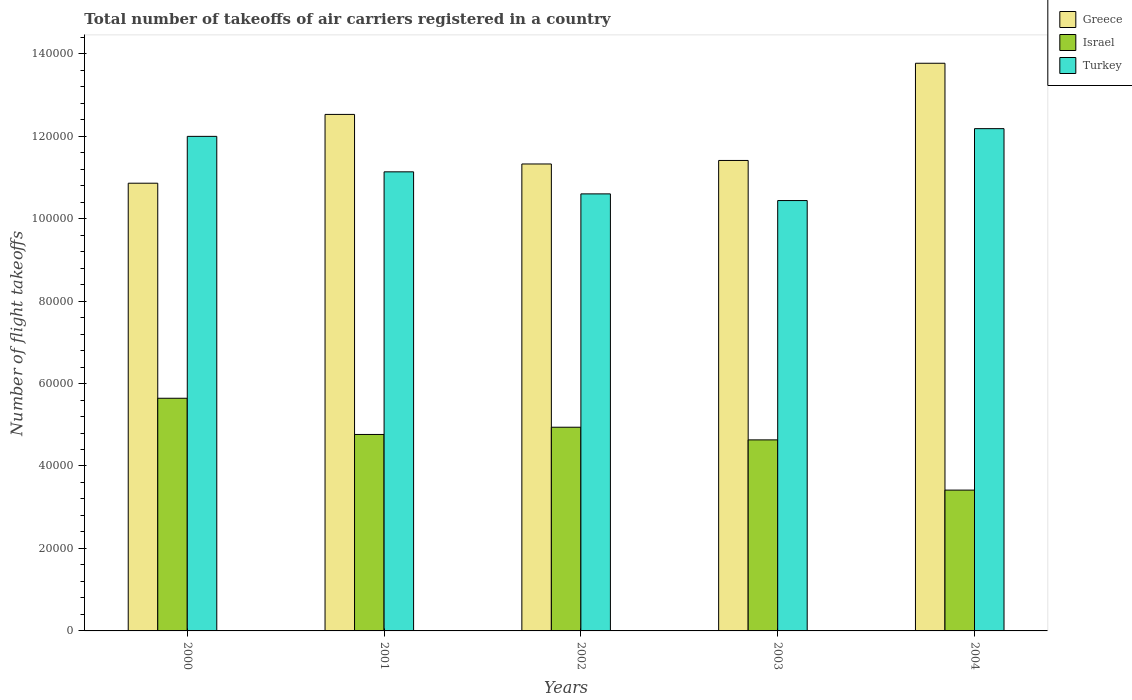How many different coloured bars are there?
Your answer should be compact. 3. How many groups of bars are there?
Your response must be concise. 5. How many bars are there on the 2nd tick from the right?
Offer a terse response. 3. What is the total number of flight takeoffs in Israel in 2001?
Give a very brief answer. 4.76e+04. Across all years, what is the maximum total number of flight takeoffs in Greece?
Ensure brevity in your answer.  1.38e+05. Across all years, what is the minimum total number of flight takeoffs in Greece?
Offer a terse response. 1.09e+05. In which year was the total number of flight takeoffs in Turkey minimum?
Offer a very short reply. 2003. What is the total total number of flight takeoffs in Turkey in the graph?
Your response must be concise. 5.63e+05. What is the difference between the total number of flight takeoffs in Greece in 2002 and that in 2004?
Offer a terse response. -2.44e+04. What is the difference between the total number of flight takeoffs in Israel in 2003 and the total number of flight takeoffs in Turkey in 2004?
Your answer should be very brief. -7.55e+04. What is the average total number of flight takeoffs in Turkey per year?
Your answer should be compact. 1.13e+05. In the year 2003, what is the difference between the total number of flight takeoffs in Israel and total number of flight takeoffs in Turkey?
Keep it short and to the point. -5.80e+04. In how many years, is the total number of flight takeoffs in Greece greater than 116000?
Your answer should be compact. 2. What is the ratio of the total number of flight takeoffs in Greece in 2001 to that in 2003?
Your response must be concise. 1.1. What is the difference between the highest and the second highest total number of flight takeoffs in Turkey?
Your response must be concise. 1870. What is the difference between the highest and the lowest total number of flight takeoffs in Israel?
Your answer should be compact. 2.23e+04. In how many years, is the total number of flight takeoffs in Greece greater than the average total number of flight takeoffs in Greece taken over all years?
Provide a succinct answer. 2. Is the sum of the total number of flight takeoffs in Turkey in 2000 and 2002 greater than the maximum total number of flight takeoffs in Greece across all years?
Make the answer very short. Yes. What does the 1st bar from the left in 2000 represents?
Offer a very short reply. Greece. What does the 1st bar from the right in 2000 represents?
Ensure brevity in your answer.  Turkey. Is it the case that in every year, the sum of the total number of flight takeoffs in Turkey and total number of flight takeoffs in Greece is greater than the total number of flight takeoffs in Israel?
Your answer should be compact. Yes. Are all the bars in the graph horizontal?
Provide a succinct answer. No. How many years are there in the graph?
Provide a succinct answer. 5. Are the values on the major ticks of Y-axis written in scientific E-notation?
Provide a succinct answer. No. Where does the legend appear in the graph?
Ensure brevity in your answer.  Top right. What is the title of the graph?
Provide a succinct answer. Total number of takeoffs of air carriers registered in a country. What is the label or title of the X-axis?
Your answer should be compact. Years. What is the label or title of the Y-axis?
Offer a very short reply. Number of flight takeoffs. What is the Number of flight takeoffs of Greece in 2000?
Offer a very short reply. 1.09e+05. What is the Number of flight takeoffs of Israel in 2000?
Keep it short and to the point. 5.64e+04. What is the Number of flight takeoffs in Turkey in 2000?
Make the answer very short. 1.20e+05. What is the Number of flight takeoffs in Greece in 2001?
Your response must be concise. 1.25e+05. What is the Number of flight takeoffs of Israel in 2001?
Your response must be concise. 4.76e+04. What is the Number of flight takeoffs in Turkey in 2001?
Give a very brief answer. 1.11e+05. What is the Number of flight takeoffs of Greece in 2002?
Make the answer very short. 1.13e+05. What is the Number of flight takeoffs in Israel in 2002?
Offer a very short reply. 4.94e+04. What is the Number of flight takeoffs of Turkey in 2002?
Your answer should be very brief. 1.06e+05. What is the Number of flight takeoffs of Greece in 2003?
Offer a very short reply. 1.14e+05. What is the Number of flight takeoffs of Israel in 2003?
Offer a terse response. 4.63e+04. What is the Number of flight takeoffs in Turkey in 2003?
Your answer should be very brief. 1.04e+05. What is the Number of flight takeoffs of Greece in 2004?
Provide a succinct answer. 1.38e+05. What is the Number of flight takeoffs of Israel in 2004?
Give a very brief answer. 3.42e+04. What is the Number of flight takeoffs of Turkey in 2004?
Keep it short and to the point. 1.22e+05. Across all years, what is the maximum Number of flight takeoffs of Greece?
Your answer should be compact. 1.38e+05. Across all years, what is the maximum Number of flight takeoffs of Israel?
Offer a very short reply. 5.64e+04. Across all years, what is the maximum Number of flight takeoffs in Turkey?
Offer a terse response. 1.22e+05. Across all years, what is the minimum Number of flight takeoffs in Greece?
Make the answer very short. 1.09e+05. Across all years, what is the minimum Number of flight takeoffs in Israel?
Make the answer very short. 3.42e+04. Across all years, what is the minimum Number of flight takeoffs of Turkey?
Keep it short and to the point. 1.04e+05. What is the total Number of flight takeoffs in Greece in the graph?
Give a very brief answer. 5.99e+05. What is the total Number of flight takeoffs of Israel in the graph?
Make the answer very short. 2.34e+05. What is the total Number of flight takeoffs of Turkey in the graph?
Your answer should be compact. 5.63e+05. What is the difference between the Number of flight takeoffs of Greece in 2000 and that in 2001?
Keep it short and to the point. -1.67e+04. What is the difference between the Number of flight takeoffs of Israel in 2000 and that in 2001?
Offer a terse response. 8779. What is the difference between the Number of flight takeoffs of Turkey in 2000 and that in 2001?
Provide a short and direct response. 8603. What is the difference between the Number of flight takeoffs in Greece in 2000 and that in 2002?
Your response must be concise. -4663. What is the difference between the Number of flight takeoffs in Israel in 2000 and that in 2002?
Give a very brief answer. 7023. What is the difference between the Number of flight takeoffs of Turkey in 2000 and that in 2002?
Offer a very short reply. 1.39e+04. What is the difference between the Number of flight takeoffs in Greece in 2000 and that in 2003?
Keep it short and to the point. -5516. What is the difference between the Number of flight takeoffs in Israel in 2000 and that in 2003?
Your answer should be compact. 1.01e+04. What is the difference between the Number of flight takeoffs in Turkey in 2000 and that in 2003?
Give a very brief answer. 1.56e+04. What is the difference between the Number of flight takeoffs of Greece in 2000 and that in 2004?
Provide a short and direct response. -2.91e+04. What is the difference between the Number of flight takeoffs of Israel in 2000 and that in 2004?
Provide a succinct answer. 2.23e+04. What is the difference between the Number of flight takeoffs in Turkey in 2000 and that in 2004?
Keep it short and to the point. -1870. What is the difference between the Number of flight takeoffs in Greece in 2001 and that in 2002?
Give a very brief answer. 1.20e+04. What is the difference between the Number of flight takeoffs of Israel in 2001 and that in 2002?
Your answer should be compact. -1756. What is the difference between the Number of flight takeoffs of Turkey in 2001 and that in 2002?
Your response must be concise. 5346. What is the difference between the Number of flight takeoffs in Greece in 2001 and that in 2003?
Offer a terse response. 1.12e+04. What is the difference between the Number of flight takeoffs of Israel in 2001 and that in 2003?
Ensure brevity in your answer.  1314. What is the difference between the Number of flight takeoffs of Turkey in 2001 and that in 2003?
Provide a short and direct response. 6965. What is the difference between the Number of flight takeoffs in Greece in 2001 and that in 2004?
Provide a succinct answer. -1.24e+04. What is the difference between the Number of flight takeoffs in Israel in 2001 and that in 2004?
Your answer should be compact. 1.35e+04. What is the difference between the Number of flight takeoffs in Turkey in 2001 and that in 2004?
Your answer should be compact. -1.05e+04. What is the difference between the Number of flight takeoffs in Greece in 2002 and that in 2003?
Your answer should be very brief. -853. What is the difference between the Number of flight takeoffs of Israel in 2002 and that in 2003?
Offer a very short reply. 3070. What is the difference between the Number of flight takeoffs in Turkey in 2002 and that in 2003?
Offer a terse response. 1619. What is the difference between the Number of flight takeoffs of Greece in 2002 and that in 2004?
Your answer should be compact. -2.44e+04. What is the difference between the Number of flight takeoffs of Israel in 2002 and that in 2004?
Offer a terse response. 1.53e+04. What is the difference between the Number of flight takeoffs in Turkey in 2002 and that in 2004?
Your answer should be very brief. -1.58e+04. What is the difference between the Number of flight takeoffs in Greece in 2003 and that in 2004?
Offer a terse response. -2.36e+04. What is the difference between the Number of flight takeoffs of Israel in 2003 and that in 2004?
Your answer should be compact. 1.22e+04. What is the difference between the Number of flight takeoffs in Turkey in 2003 and that in 2004?
Ensure brevity in your answer.  -1.74e+04. What is the difference between the Number of flight takeoffs of Greece in 2000 and the Number of flight takeoffs of Israel in 2001?
Provide a succinct answer. 6.09e+04. What is the difference between the Number of flight takeoffs of Greece in 2000 and the Number of flight takeoffs of Turkey in 2001?
Your response must be concise. -2758. What is the difference between the Number of flight takeoffs of Israel in 2000 and the Number of flight takeoffs of Turkey in 2001?
Provide a short and direct response. -5.49e+04. What is the difference between the Number of flight takeoffs of Greece in 2000 and the Number of flight takeoffs of Israel in 2002?
Your answer should be compact. 5.92e+04. What is the difference between the Number of flight takeoffs of Greece in 2000 and the Number of flight takeoffs of Turkey in 2002?
Make the answer very short. 2588. What is the difference between the Number of flight takeoffs of Israel in 2000 and the Number of flight takeoffs of Turkey in 2002?
Ensure brevity in your answer.  -4.96e+04. What is the difference between the Number of flight takeoffs in Greece in 2000 and the Number of flight takeoffs in Israel in 2003?
Offer a terse response. 6.22e+04. What is the difference between the Number of flight takeoffs in Greece in 2000 and the Number of flight takeoffs in Turkey in 2003?
Your response must be concise. 4207. What is the difference between the Number of flight takeoffs of Israel in 2000 and the Number of flight takeoffs of Turkey in 2003?
Provide a short and direct response. -4.80e+04. What is the difference between the Number of flight takeoffs in Greece in 2000 and the Number of flight takeoffs in Israel in 2004?
Provide a succinct answer. 7.44e+04. What is the difference between the Number of flight takeoffs in Greece in 2000 and the Number of flight takeoffs in Turkey in 2004?
Provide a short and direct response. -1.32e+04. What is the difference between the Number of flight takeoffs in Israel in 2000 and the Number of flight takeoffs in Turkey in 2004?
Your answer should be compact. -6.54e+04. What is the difference between the Number of flight takeoffs in Greece in 2001 and the Number of flight takeoffs in Israel in 2002?
Offer a terse response. 7.59e+04. What is the difference between the Number of flight takeoffs in Greece in 2001 and the Number of flight takeoffs in Turkey in 2002?
Your response must be concise. 1.93e+04. What is the difference between the Number of flight takeoffs in Israel in 2001 and the Number of flight takeoffs in Turkey in 2002?
Make the answer very short. -5.83e+04. What is the difference between the Number of flight takeoffs of Greece in 2001 and the Number of flight takeoffs of Israel in 2003?
Your answer should be compact. 7.89e+04. What is the difference between the Number of flight takeoffs of Greece in 2001 and the Number of flight takeoffs of Turkey in 2003?
Ensure brevity in your answer.  2.09e+04. What is the difference between the Number of flight takeoffs of Israel in 2001 and the Number of flight takeoffs of Turkey in 2003?
Make the answer very short. -5.67e+04. What is the difference between the Number of flight takeoffs in Greece in 2001 and the Number of flight takeoffs in Israel in 2004?
Make the answer very short. 9.11e+04. What is the difference between the Number of flight takeoffs of Greece in 2001 and the Number of flight takeoffs of Turkey in 2004?
Keep it short and to the point. 3454. What is the difference between the Number of flight takeoffs in Israel in 2001 and the Number of flight takeoffs in Turkey in 2004?
Ensure brevity in your answer.  -7.42e+04. What is the difference between the Number of flight takeoffs of Greece in 2002 and the Number of flight takeoffs of Israel in 2003?
Your response must be concise. 6.69e+04. What is the difference between the Number of flight takeoffs in Greece in 2002 and the Number of flight takeoffs in Turkey in 2003?
Provide a succinct answer. 8870. What is the difference between the Number of flight takeoffs in Israel in 2002 and the Number of flight takeoffs in Turkey in 2003?
Offer a terse response. -5.50e+04. What is the difference between the Number of flight takeoffs of Greece in 2002 and the Number of flight takeoffs of Israel in 2004?
Your answer should be very brief. 7.91e+04. What is the difference between the Number of flight takeoffs of Greece in 2002 and the Number of flight takeoffs of Turkey in 2004?
Provide a succinct answer. -8568. What is the difference between the Number of flight takeoffs in Israel in 2002 and the Number of flight takeoffs in Turkey in 2004?
Give a very brief answer. -7.24e+04. What is the difference between the Number of flight takeoffs of Greece in 2003 and the Number of flight takeoffs of Israel in 2004?
Ensure brevity in your answer.  7.99e+04. What is the difference between the Number of flight takeoffs in Greece in 2003 and the Number of flight takeoffs in Turkey in 2004?
Ensure brevity in your answer.  -7715. What is the difference between the Number of flight takeoffs of Israel in 2003 and the Number of flight takeoffs of Turkey in 2004?
Make the answer very short. -7.55e+04. What is the average Number of flight takeoffs of Greece per year?
Make the answer very short. 1.20e+05. What is the average Number of flight takeoffs in Israel per year?
Offer a very short reply. 4.68e+04. What is the average Number of flight takeoffs in Turkey per year?
Your response must be concise. 1.13e+05. In the year 2000, what is the difference between the Number of flight takeoffs in Greece and Number of flight takeoffs in Israel?
Ensure brevity in your answer.  5.22e+04. In the year 2000, what is the difference between the Number of flight takeoffs of Greece and Number of flight takeoffs of Turkey?
Give a very brief answer. -1.14e+04. In the year 2000, what is the difference between the Number of flight takeoffs in Israel and Number of flight takeoffs in Turkey?
Make the answer very short. -6.35e+04. In the year 2001, what is the difference between the Number of flight takeoffs in Greece and Number of flight takeoffs in Israel?
Provide a succinct answer. 7.76e+04. In the year 2001, what is the difference between the Number of flight takeoffs in Greece and Number of flight takeoffs in Turkey?
Offer a terse response. 1.39e+04. In the year 2001, what is the difference between the Number of flight takeoffs in Israel and Number of flight takeoffs in Turkey?
Make the answer very short. -6.37e+04. In the year 2002, what is the difference between the Number of flight takeoffs of Greece and Number of flight takeoffs of Israel?
Give a very brief answer. 6.38e+04. In the year 2002, what is the difference between the Number of flight takeoffs of Greece and Number of flight takeoffs of Turkey?
Provide a succinct answer. 7251. In the year 2002, what is the difference between the Number of flight takeoffs of Israel and Number of flight takeoffs of Turkey?
Make the answer very short. -5.66e+04. In the year 2003, what is the difference between the Number of flight takeoffs of Greece and Number of flight takeoffs of Israel?
Offer a terse response. 6.78e+04. In the year 2003, what is the difference between the Number of flight takeoffs of Greece and Number of flight takeoffs of Turkey?
Your answer should be very brief. 9723. In the year 2003, what is the difference between the Number of flight takeoffs in Israel and Number of flight takeoffs in Turkey?
Offer a terse response. -5.80e+04. In the year 2004, what is the difference between the Number of flight takeoffs in Greece and Number of flight takeoffs in Israel?
Your answer should be very brief. 1.04e+05. In the year 2004, what is the difference between the Number of flight takeoffs of Greece and Number of flight takeoffs of Turkey?
Give a very brief answer. 1.59e+04. In the year 2004, what is the difference between the Number of flight takeoffs of Israel and Number of flight takeoffs of Turkey?
Ensure brevity in your answer.  -8.77e+04. What is the ratio of the Number of flight takeoffs in Greece in 2000 to that in 2001?
Your answer should be very brief. 0.87. What is the ratio of the Number of flight takeoffs in Israel in 2000 to that in 2001?
Your answer should be very brief. 1.18. What is the ratio of the Number of flight takeoffs of Turkey in 2000 to that in 2001?
Provide a short and direct response. 1.08. What is the ratio of the Number of flight takeoffs in Greece in 2000 to that in 2002?
Offer a very short reply. 0.96. What is the ratio of the Number of flight takeoffs in Israel in 2000 to that in 2002?
Make the answer very short. 1.14. What is the ratio of the Number of flight takeoffs in Turkey in 2000 to that in 2002?
Offer a very short reply. 1.13. What is the ratio of the Number of flight takeoffs in Greece in 2000 to that in 2003?
Make the answer very short. 0.95. What is the ratio of the Number of flight takeoffs of Israel in 2000 to that in 2003?
Give a very brief answer. 1.22. What is the ratio of the Number of flight takeoffs in Turkey in 2000 to that in 2003?
Offer a terse response. 1.15. What is the ratio of the Number of flight takeoffs of Greece in 2000 to that in 2004?
Your answer should be compact. 0.79. What is the ratio of the Number of flight takeoffs in Israel in 2000 to that in 2004?
Provide a short and direct response. 1.65. What is the ratio of the Number of flight takeoffs of Turkey in 2000 to that in 2004?
Your response must be concise. 0.98. What is the ratio of the Number of flight takeoffs of Greece in 2001 to that in 2002?
Ensure brevity in your answer.  1.11. What is the ratio of the Number of flight takeoffs of Israel in 2001 to that in 2002?
Your response must be concise. 0.96. What is the ratio of the Number of flight takeoffs in Turkey in 2001 to that in 2002?
Give a very brief answer. 1.05. What is the ratio of the Number of flight takeoffs in Greece in 2001 to that in 2003?
Provide a short and direct response. 1.1. What is the ratio of the Number of flight takeoffs of Israel in 2001 to that in 2003?
Your answer should be very brief. 1.03. What is the ratio of the Number of flight takeoffs of Turkey in 2001 to that in 2003?
Your response must be concise. 1.07. What is the ratio of the Number of flight takeoffs in Greece in 2001 to that in 2004?
Ensure brevity in your answer.  0.91. What is the ratio of the Number of flight takeoffs of Israel in 2001 to that in 2004?
Your answer should be compact. 1.4. What is the ratio of the Number of flight takeoffs in Turkey in 2001 to that in 2004?
Offer a very short reply. 0.91. What is the ratio of the Number of flight takeoffs of Greece in 2002 to that in 2003?
Your answer should be very brief. 0.99. What is the ratio of the Number of flight takeoffs of Israel in 2002 to that in 2003?
Provide a short and direct response. 1.07. What is the ratio of the Number of flight takeoffs of Turkey in 2002 to that in 2003?
Make the answer very short. 1.02. What is the ratio of the Number of flight takeoffs in Greece in 2002 to that in 2004?
Make the answer very short. 0.82. What is the ratio of the Number of flight takeoffs of Israel in 2002 to that in 2004?
Your answer should be very brief. 1.45. What is the ratio of the Number of flight takeoffs of Turkey in 2002 to that in 2004?
Keep it short and to the point. 0.87. What is the ratio of the Number of flight takeoffs in Greece in 2003 to that in 2004?
Your answer should be compact. 0.83. What is the ratio of the Number of flight takeoffs of Israel in 2003 to that in 2004?
Your answer should be compact. 1.36. What is the ratio of the Number of flight takeoffs in Turkey in 2003 to that in 2004?
Provide a succinct answer. 0.86. What is the difference between the highest and the second highest Number of flight takeoffs in Greece?
Keep it short and to the point. 1.24e+04. What is the difference between the highest and the second highest Number of flight takeoffs in Israel?
Offer a very short reply. 7023. What is the difference between the highest and the second highest Number of flight takeoffs of Turkey?
Your answer should be compact. 1870. What is the difference between the highest and the lowest Number of flight takeoffs in Greece?
Offer a very short reply. 2.91e+04. What is the difference between the highest and the lowest Number of flight takeoffs of Israel?
Your answer should be compact. 2.23e+04. What is the difference between the highest and the lowest Number of flight takeoffs of Turkey?
Give a very brief answer. 1.74e+04. 